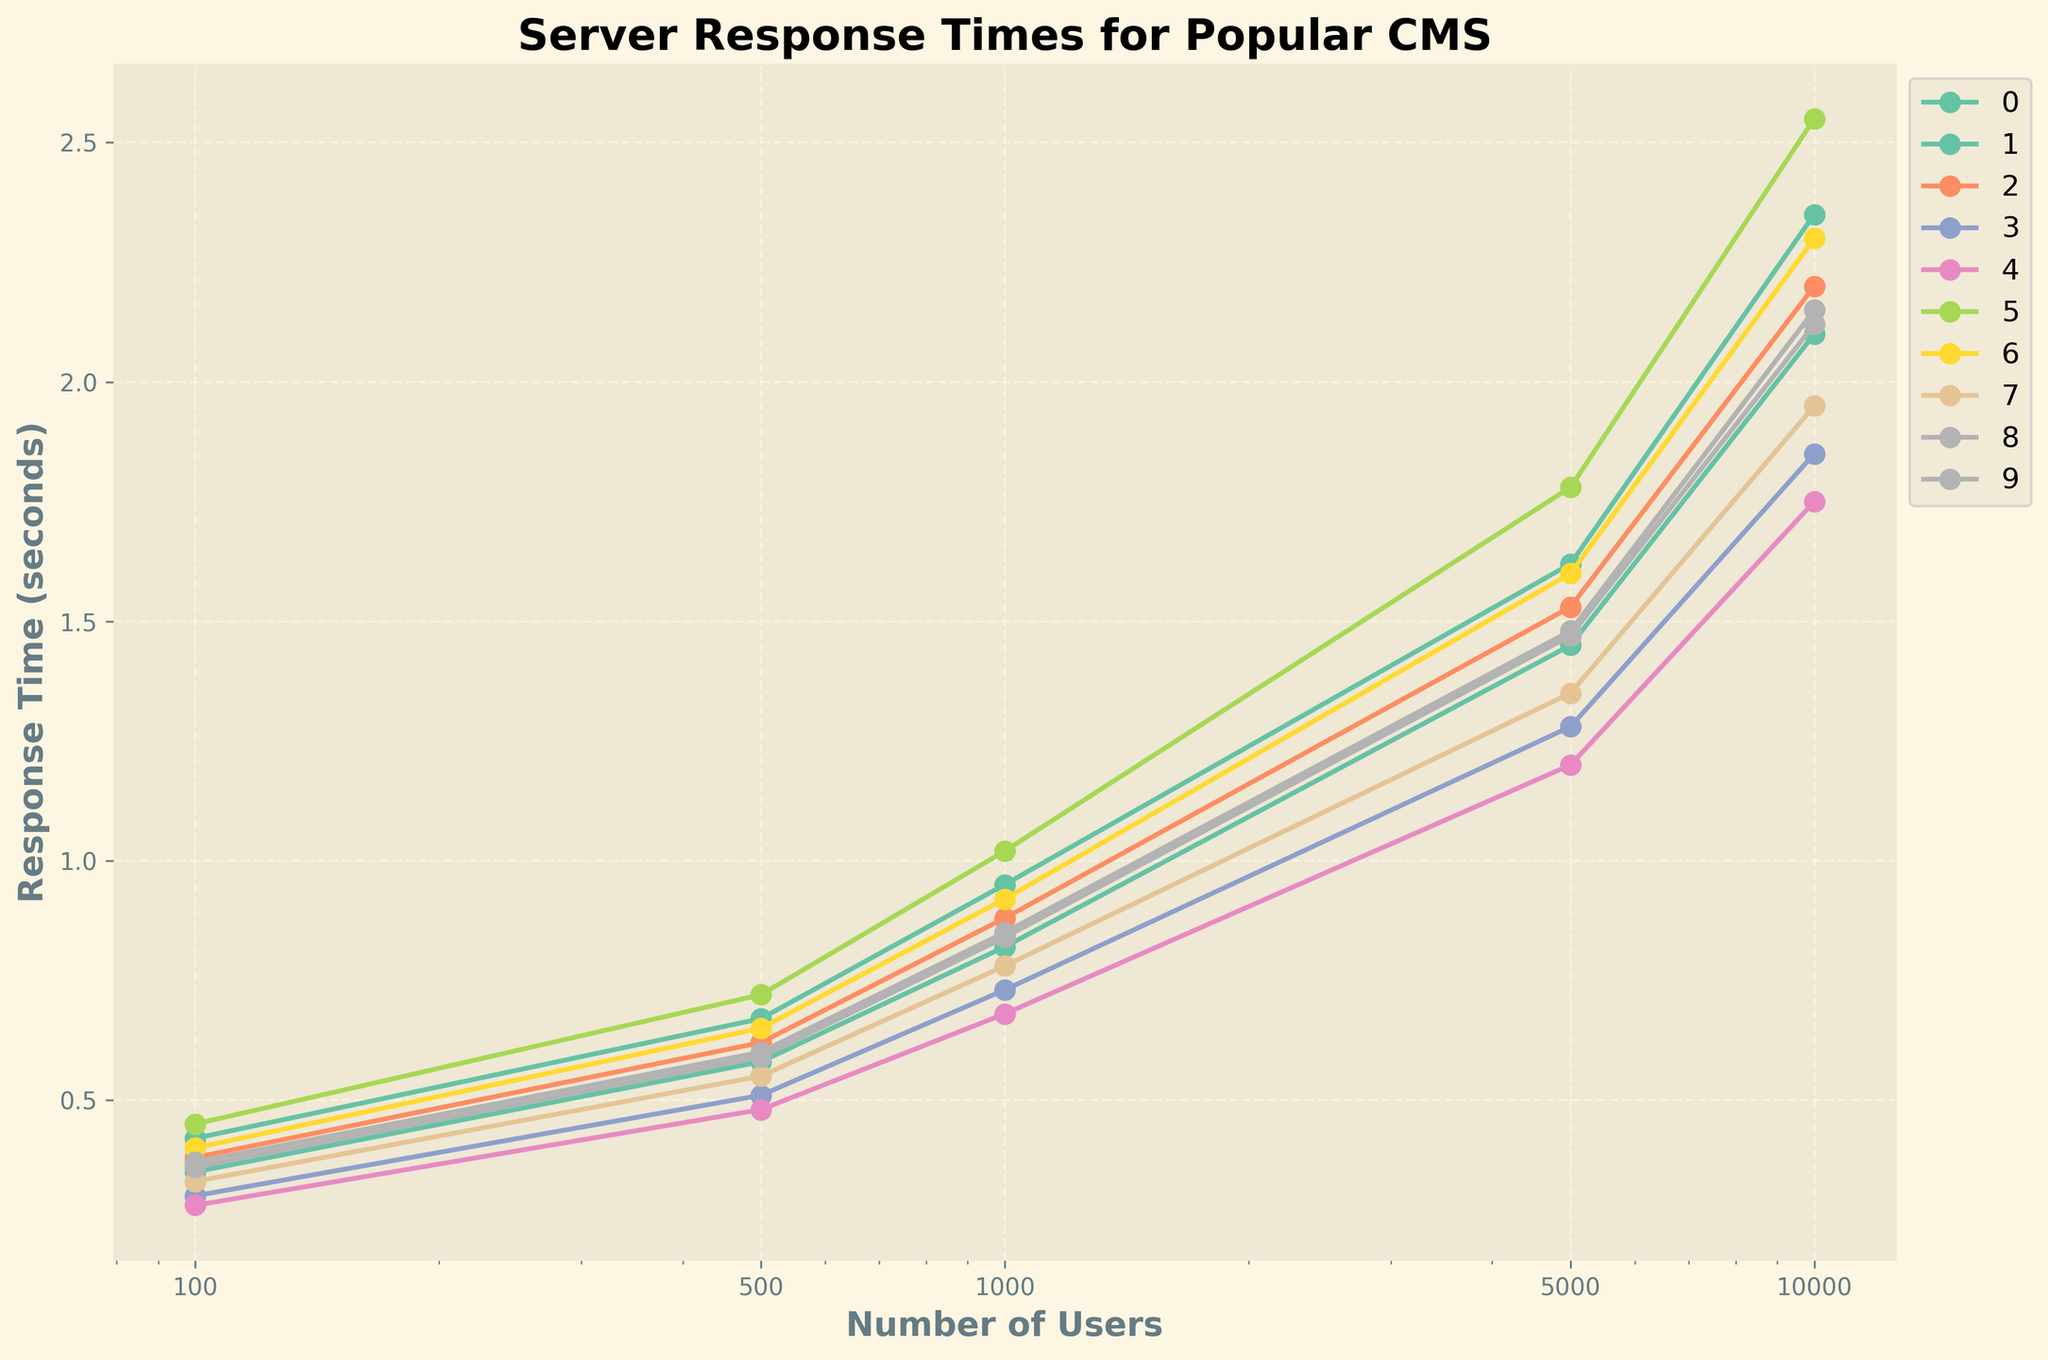Which CMS has the fastest response time for 100 users? Look for the smallest y-value among all lines at the x=100 mark in the plot.
Answer: Medium Which CMS shows the steepest increase in response time from 100 to 1000 users? Identify which line has the greatest vertical distance between the y-values at x=100 and x=1000.
Answer: Wix Does Drupal ever have the lowest response time compared to other CMSs at any user load? Examine each segment of the line corresponding to Drupal (color-coded) and compare it with others at all x values to see if it is ever the lowest.
Answer: No What is the range of response times for WordPress at the highest user load? Find the y-values at x=10000 for WordPress and calculate the range by subtracting the minimum y-value from the maximum y-value.
Answer: 2.10 - 0.35 = 1.75 Compare the response times of Ghost and Joomla for 500 users. Which one is faster? Look at the y-values for Ghost and Joomla at the x=500 mark in the plot, and identify the smaller one.
Answer: Ghost (0.51 vs 0.62) Which CMS has the least increase in response time from 5000 to 10000 users? Compare the differences in y-values between x=5000 and x=10000 for each CMS and identify the smallest difference.
Answer: Medium (1.75 - 1.20 = 0.55) How does Shopify's response time at 5000 users compare to HubSpot CMS at the same load? Look at the y-values for Shopify and HubSpot CMS at x=5000 and compare them.
Answer: They are very close (1.48 for Shopify vs 1.47 for HubSpot) Which CMS consistently has the highest response times as user loads increase? Identify the line that has the highest y-values at almost all x points.
Answer: Wix Calculate the average response time for Webflow from 100 to 10000 users. Sum the y-values for Webflow at all x points and divide by the number of points (5). Average = (0.33 + 0.55 + 0.78 + 1.35 + 1.95) / 5 = 1.392
Answer: 1.392 Compare the response times of all CMSs for 10000 users and determine which has the best performance. Look at the y-values at x=10000 for all the CMSs and identify the smallest one.
Answer: Medium (1.75) 